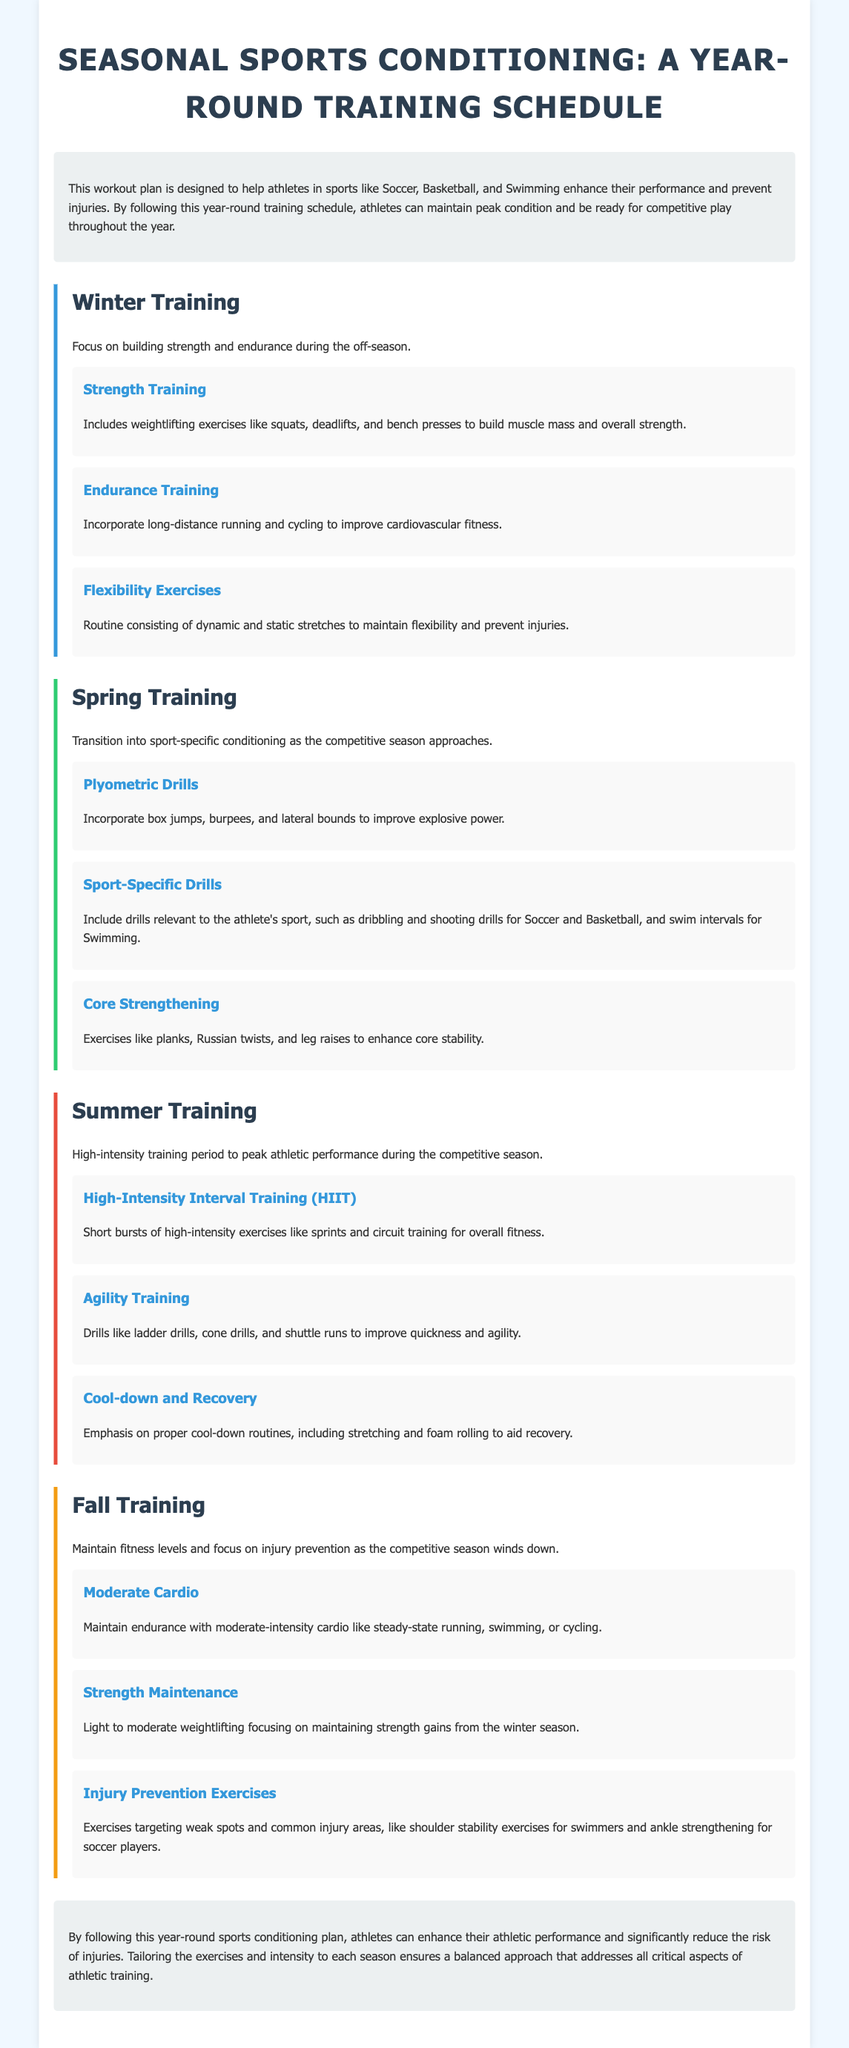What is the title of the document? The title is mentioned at the top of the document in a prominent way.
Answer: Seasonal Sports Conditioning: A Year-Round Training Schedule What is the main focus of the Winter Training section? The main focus is specified in the introduction of the Winter Training section.
Answer: Building strength and endurance Which sport-specific drills are mentioned in the Spring Training? Sport-specific drills are detailed within the Spring Training section.
Answer: Dribbling and shooting drills for Soccer and Basketball, swim intervals for Swimming How many workouts are listed under Summer Training? The Summer Training section outlines the number of workouts included.
Answer: Three What type of training is emphasized during the Summer Training? The emphasis is described in the summary of the Summer Training section.
Answer: High-intensity training What is a key benefit of following the year-round sports conditioning plan? The benefits are summarized in the conclusion of the document.
Answer: Enhance athletic performance and reduce the risk of injuries What type of exercises are included in the Fall Training for injury prevention? The exercises are outlined specifically in the Fall Training section.
Answer: Targeting weak spots and common injury areas Which flexibility exercises are mentioned for the Winter? The types of flexibility exercises are described in the Winter Training section.
Answer: Dynamic and static stretches 